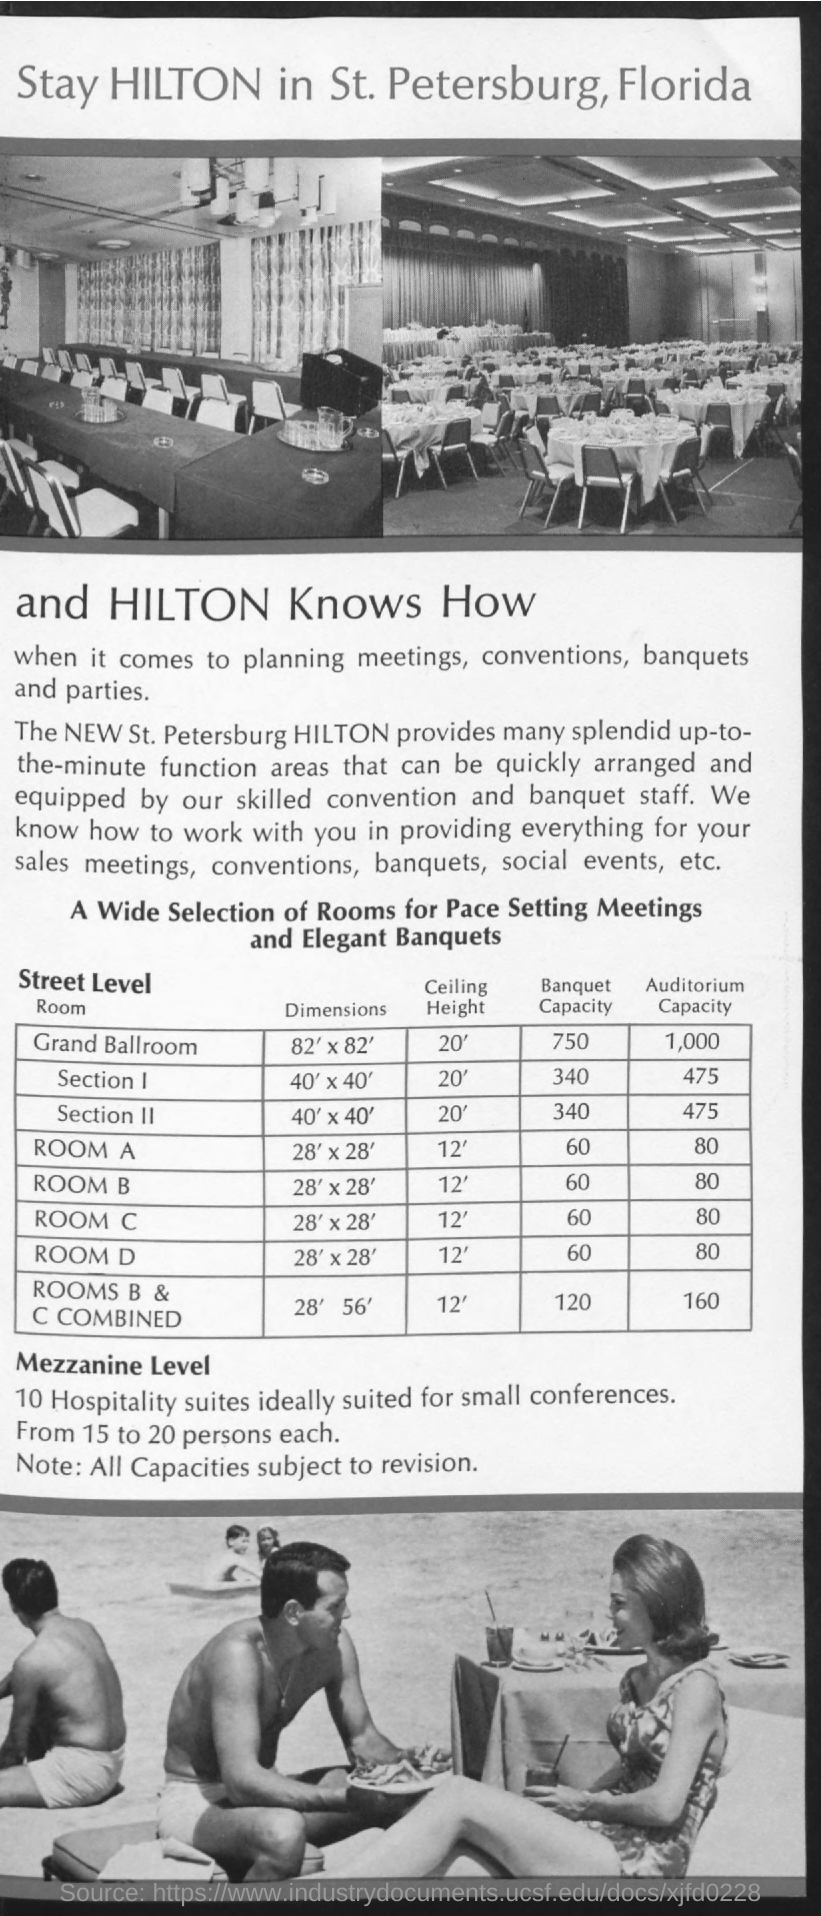Indicate a few pertinent items in this graphic. The Grand Ballroom has a banquet capacity of 750. The ceiling height in Room A is 12 feet. The auditorium capacity of Room A is 80. The Grand Ballroom has a ceiling height of 20 feet. The Grand Ballroom has a capacity of 1,000. 